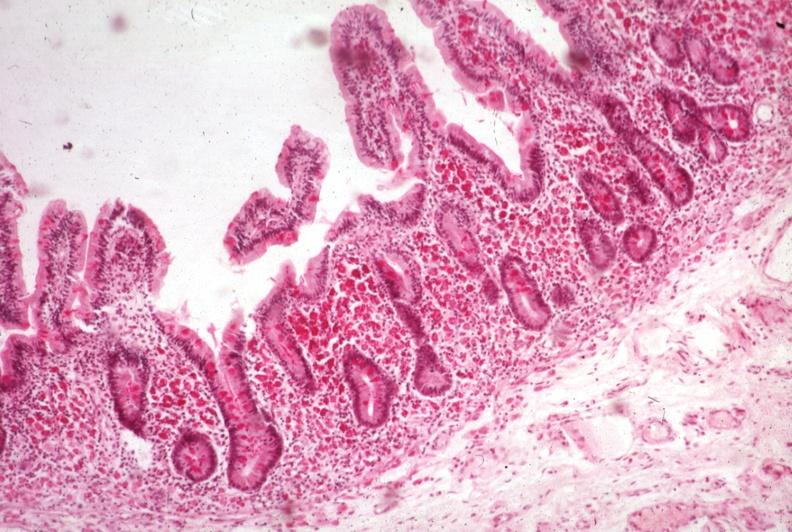s whipples disease present?
Answer the question using a single word or phrase. Yes 